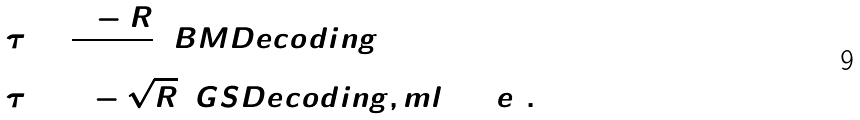<formula> <loc_0><loc_0><loc_500><loc_500>& \tau = \frac { 1 - R } { 2 } \, ( B M D e c o d i n g ) \\ & \tau = 1 - \sqrt { R } \, ( G S D e c o d i n g , m l \arg e ) .</formula> 